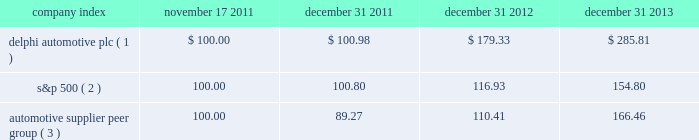Stock performance graph * $ 100 invested on 11/17/11 in our stock or 10/31/11 in the relevant index , including reinvestment of dividends .
Fiscal year ending december 31 , 2013 .
( 1 ) delphi automotive plc ( 2 ) s&p 500 2013 standard & poor 2019s 500 total return index ( 3 ) automotive supplier peer group 2013 russell 3000 auto parts index , including american axle & manufacturing , borgwarner inc. , cooper tire & rubber company , dana holding corp. , delphi automotive plc , dorman products inc. , federal-mogul corp. , ford motor co. , fuel systems solutions inc. , general motors co. , gentex corp. , gentherm inc. , genuine parts co. , johnson controls inc. , lkq corp. , lear corp. , meritor inc. , remy international inc. , standard motor products inc. , stoneridge inc. , superior industries international , trw automotive holdings corp. , tenneco inc. , tesla motors inc. , the goodyear tire & rubber co. , tower international inc. , visteon corp. , and wabco holdings inc .
Company index november 17 , december 31 , december 31 , december 31 .
Dividends on february 26 , 2013 , the board of directors approved the initiation of dividend payments on the company's ordinary shares .
The board of directors declared a regular quarterly cash dividend of $ 0.17 per ordinary share that was paid in each quarter of 2013 .
In addition , in january 2014 , the board of directors declared a regular quarterly cash dividend of $ 0.25 per ordinary share , payable on february 27 , 2014 to shareholders of record at the close of business on february 18 , 2014 .
In october 2011 , the board of managers of delphi automotive llp approved a distribution of approximately $ 95 million , which was paid on december 5 , 2011 , principally in respect of taxes , to members of delphi automotive llp who held membership interests as of the close of business on october 31 , 2011. .
What is the lowest return for the first year of the investment? 
Rationale: it is the minimum value , turned into a percentage .
Computations: (110.41 - 100)
Answer: 10.41. 